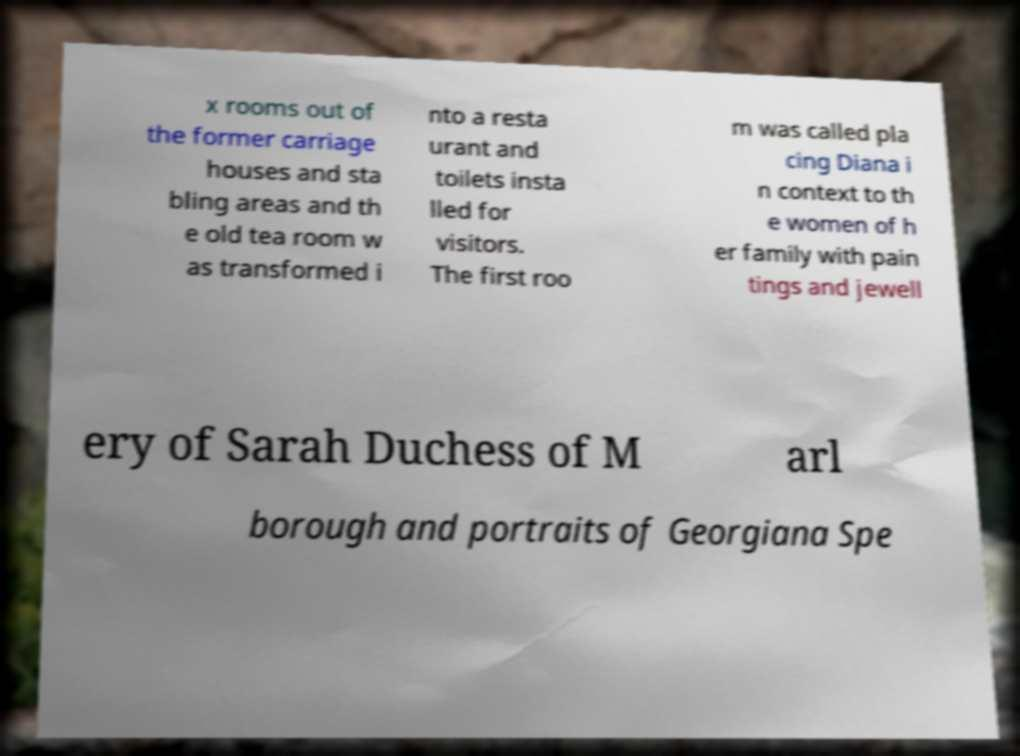Please read and relay the text visible in this image. What does it say? x rooms out of the former carriage houses and sta bling areas and th e old tea room w as transformed i nto a resta urant and toilets insta lled for visitors. The first roo m was called pla cing Diana i n context to th e women of h er family with pain tings and jewell ery of Sarah Duchess of M arl borough and portraits of Georgiana Spe 